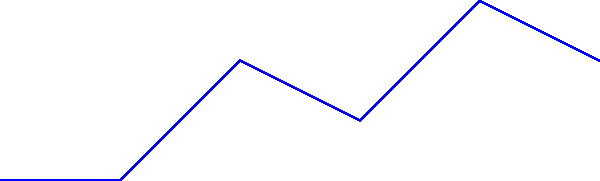Consider a cyclist riding on varying terrain as shown in the diagram. Which force is likely to have the greatest magnitude when the cyclist is traveling uphill, and how does this relate to the environmental impact of cycling compared to electric vehicles? To answer this question, let's analyze the forces acting on the cyclist:

1. Normal force: Perpendicular to the surface, balancing the component of gravity perpendicular to the slope.
2. Gravity: Always downward, constant magnitude.
3. Friction: Opposes motion, parallel to the surface.
4. Air resistance: Opposes motion, depends on velocity.

When cycling uphill:
1. The component of gravity parallel to the slope increases, making it harder to move forward.
2. To overcome this, the cyclist must exert more force on the pedals, increasing the friction force between the tires and the road.
3. The normal force decreases slightly as the slope increases.
4. Air resistance remains relatively constant at low speeds.

Among these forces, gravity is likely to have the greatest magnitude, as it's constant regardless of the terrain. However, the friction force becomes significantly larger when cycling uphill to overcome the increased gravitational component opposing motion.

Relating this to environmental impact:
1. Cycling, even uphill, produces zero direct emissions, unlike electric vehicles which indirectly produce emissions through electricity generation.
2. The increased effort required to cycle uphill is powered by the rider's own energy, which is renewable and has a minimal environmental footprint.
3. Electric vehicles would consume more energy going uphill, potentially increasing their environmental impact depending on the source of electricity.
4. The manufacturing process for bicycles generally has a lower environmental impact than that of electric vehicles, further reducing the overall carbon footprint of cycling.

In conclusion, while cycling uphill requires more effort due to increased friction and gravitational forces, it remains an environmentally friendly mode of transportation compared to electric vehicles, aligning with the interests of someone passionate about climate change.
Answer: Gravity; cycling remains more environmentally friendly than electric vehicles due to zero emissions and lower overall carbon footprint. 